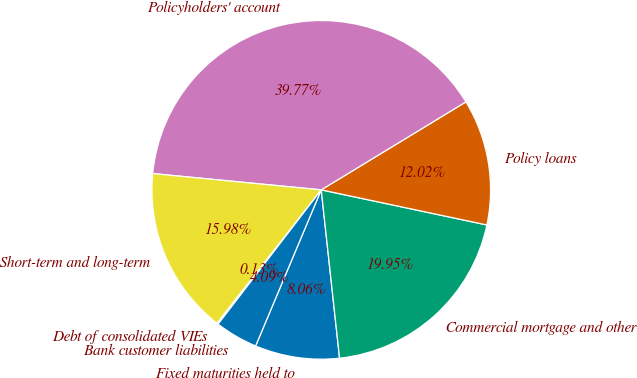Convert chart. <chart><loc_0><loc_0><loc_500><loc_500><pie_chart><fcel>Fixed maturities held to<fcel>Commercial mortgage and other<fcel>Policy loans<fcel>Policyholders' account<fcel>Short-term and long-term<fcel>Debt of consolidated VIEs<fcel>Bank customer liabilities<nl><fcel>8.06%<fcel>19.95%<fcel>12.02%<fcel>39.77%<fcel>15.98%<fcel>0.13%<fcel>4.09%<nl></chart> 